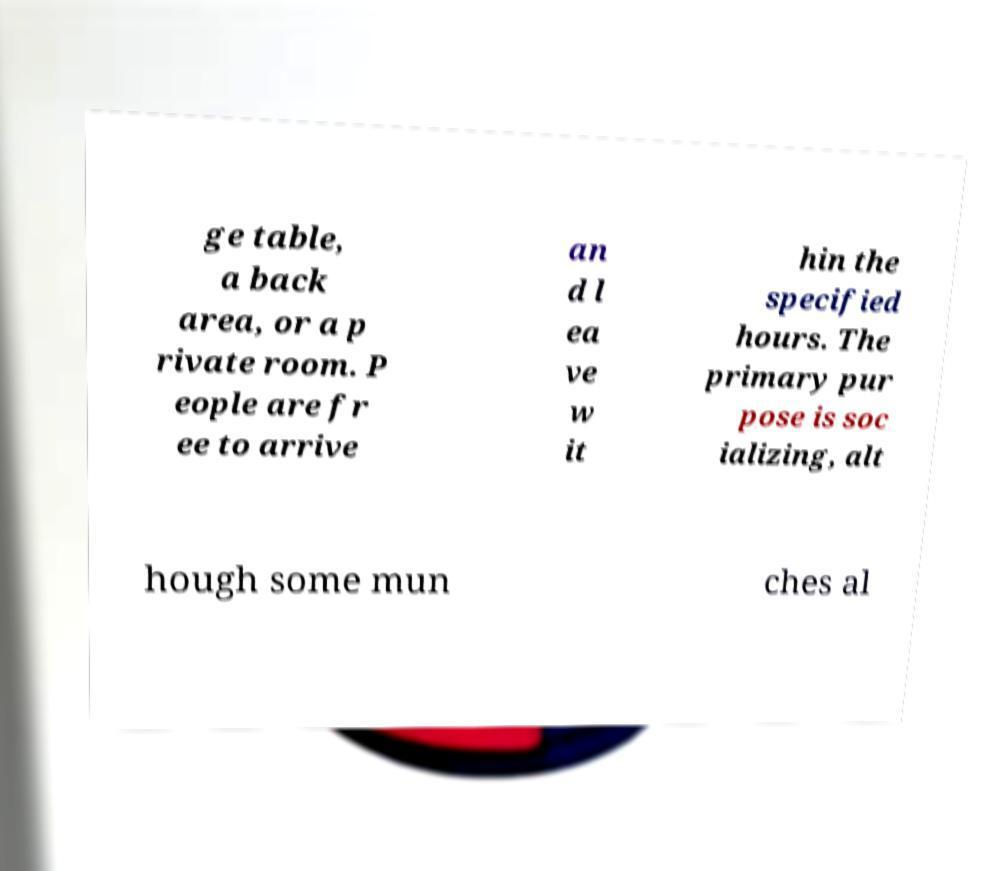Can you accurately transcribe the text from the provided image for me? ge table, a back area, or a p rivate room. P eople are fr ee to arrive an d l ea ve w it hin the specified hours. The primary pur pose is soc ializing, alt hough some mun ches al 